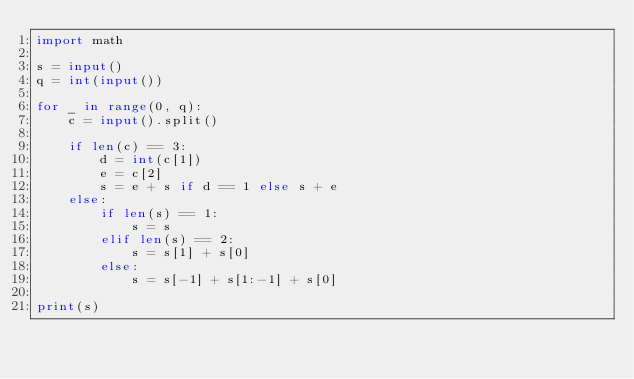<code> <loc_0><loc_0><loc_500><loc_500><_Python_>import math

s = input()
q = int(input())

for _ in range(0, q):
    c = input().split()

    if len(c) == 3:
        d = int(c[1])
        e = c[2]
        s = e + s if d == 1 else s + e
    else:
        if len(s) == 1:
            s = s
        elif len(s) == 2:
            s = s[1] + s[0]
        else:
            s = s[-1] + s[1:-1] + s[0]

print(s)</code> 